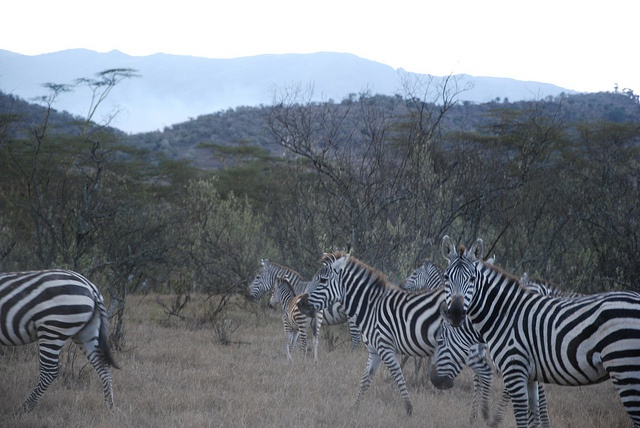Describe the objects in this image and their specific colors. I can see zebra in white, black, gray, and darkgray tones, zebra in white, gray, black, and darkgray tones, zebra in white, gray, black, and darkgray tones, zebra in white, gray, black, and darkgray tones, and zebra in white, gray, and black tones in this image. 